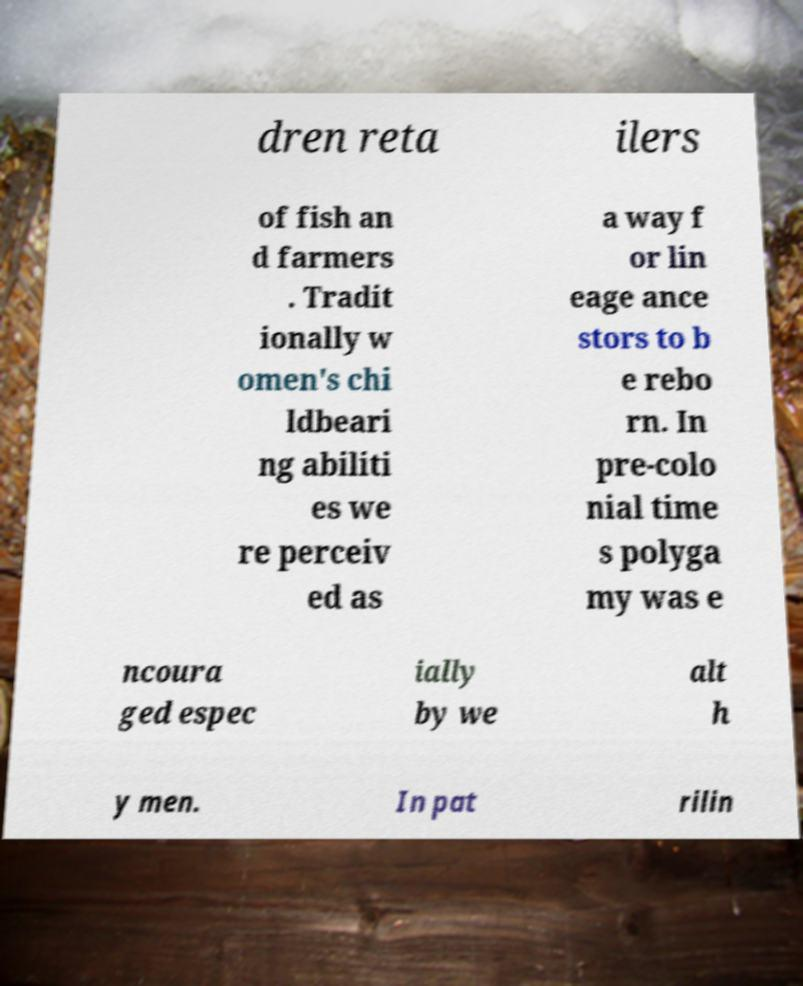I need the written content from this picture converted into text. Can you do that? dren reta ilers of fish an d farmers . Tradit ionally w omen's chi ldbeari ng abiliti es we re perceiv ed as a way f or lin eage ance stors to b e rebo rn. In pre-colo nial time s polyga my was e ncoura ged espec ially by we alt h y men. In pat rilin 